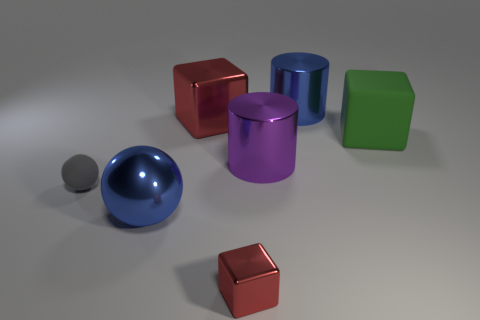Is the number of small spheres greater than the number of matte objects?
Ensure brevity in your answer.  No. How many shiny objects are either small brown cubes or gray spheres?
Offer a very short reply. 0. How many big shiny things are the same color as the big metal sphere?
Your response must be concise. 1. What is the material of the cube that is to the right of the metallic cylinder that is behind the big red block on the left side of the large green matte block?
Offer a very short reply. Rubber. There is a big metallic cube that is in front of the big blue metal object right of the large purple cylinder; what color is it?
Your answer should be very brief. Red. What number of big objects are either gray rubber balls or green metallic things?
Make the answer very short. 0. How many purple cylinders are the same material as the large purple thing?
Provide a short and direct response. 0. There is a blue object in front of the large red shiny cube; how big is it?
Provide a short and direct response. Large. The large blue metal thing that is to the right of the red metallic thing in front of the big metallic sphere is what shape?
Ensure brevity in your answer.  Cylinder. What number of big cubes are on the right side of the large blue cylinder to the right of the small thing to the right of the blue metallic sphere?
Make the answer very short. 1. 